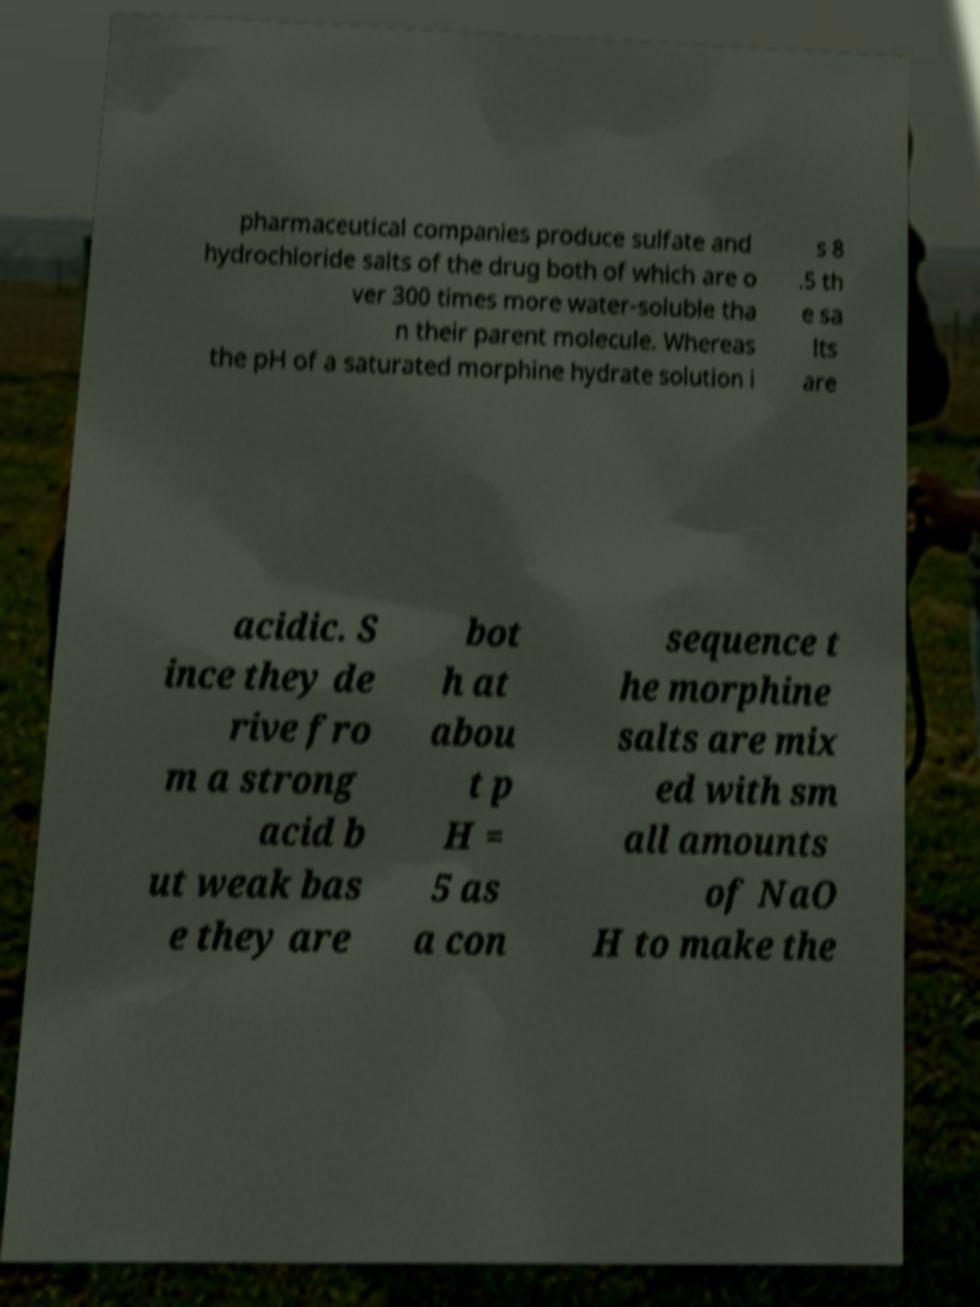I need the written content from this picture converted into text. Can you do that? pharmaceutical companies produce sulfate and hydrochloride salts of the drug both of which are o ver 300 times more water-soluble tha n their parent molecule. Whereas the pH of a saturated morphine hydrate solution i s 8 .5 th e sa lts are acidic. S ince they de rive fro m a strong acid b ut weak bas e they are bot h at abou t p H = 5 as a con sequence t he morphine salts are mix ed with sm all amounts of NaO H to make the 